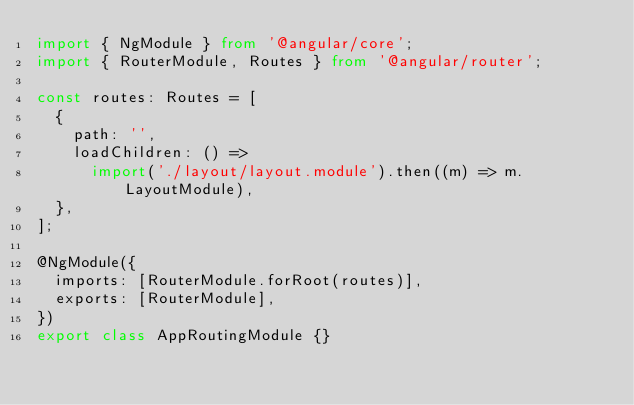Convert code to text. <code><loc_0><loc_0><loc_500><loc_500><_TypeScript_>import { NgModule } from '@angular/core';
import { RouterModule, Routes } from '@angular/router';

const routes: Routes = [
  {
    path: '',
    loadChildren: () =>
      import('./layout/layout.module').then((m) => m.LayoutModule),
  },
];

@NgModule({
  imports: [RouterModule.forRoot(routes)],
  exports: [RouterModule],
})
export class AppRoutingModule {}
</code> 